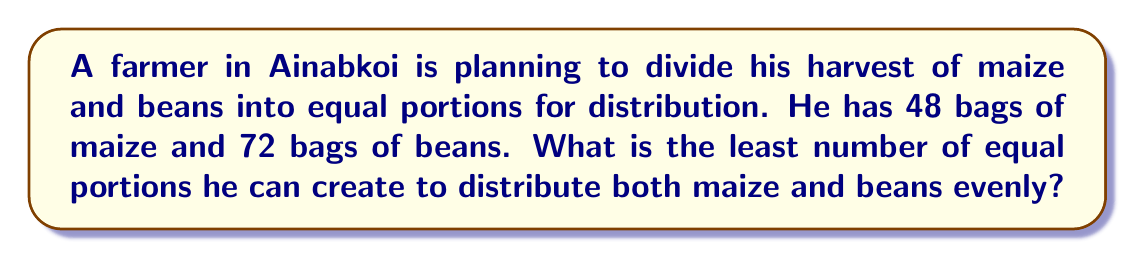Teach me how to tackle this problem. To solve this problem, we need to find the Least Common Multiple (LCM) of 48 and 72.

Step 1: Prime factorization of 48 and 72
$$48 = 2^4 \times 3$$
$$72 = 2^3 \times 3^2$$

Step 2: Identify the highest power of each prime factor
For 2: $2^4$ (from 48)
For 3: $3^2$ (from 72)

Step 3: Multiply these highest powers
$$LCM = 2^4 \times 3^2 = 16 \times 9 = 144$$

Therefore, the farmer can create 144 equal portions, which is the least number that allows both 48 and 72 to be divided evenly.

Verification:
$144 \div 48 = 3$ (each portion will have 1/3 bag of maize)
$144 \div 72 = 2$ (each portion will have 1/2 bag of beans)
Answer: 144 portions 